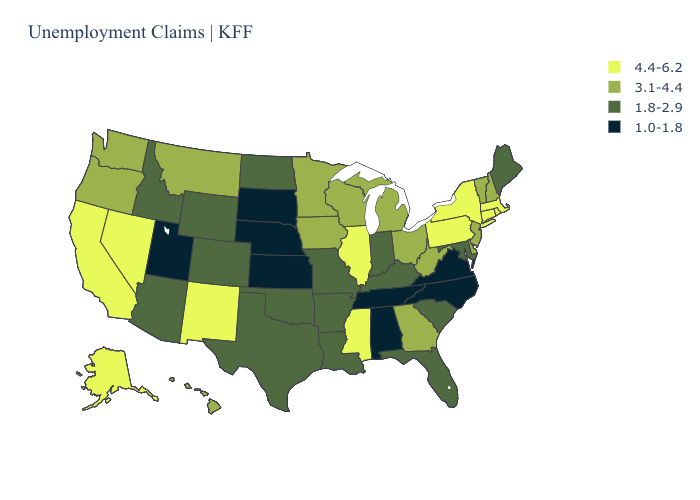What is the highest value in the USA?
Write a very short answer. 4.4-6.2. Among the states that border Michigan , does Wisconsin have the lowest value?
Concise answer only. No. Name the states that have a value in the range 1.0-1.8?
Give a very brief answer. Alabama, Kansas, Nebraska, North Carolina, South Dakota, Tennessee, Utah, Virginia. Does Illinois have the highest value in the MidWest?
Keep it brief. Yes. Name the states that have a value in the range 1.8-2.9?
Give a very brief answer. Arizona, Arkansas, Colorado, Florida, Idaho, Indiana, Kentucky, Louisiana, Maine, Maryland, Missouri, North Dakota, Oklahoma, South Carolina, Texas, Wyoming. What is the value of Pennsylvania?
Be succinct. 4.4-6.2. What is the value of New Mexico?
Give a very brief answer. 4.4-6.2. Does Iowa have the highest value in the USA?
Write a very short answer. No. Name the states that have a value in the range 4.4-6.2?
Write a very short answer. Alaska, California, Connecticut, Illinois, Massachusetts, Mississippi, Nevada, New Mexico, New York, Pennsylvania, Rhode Island. Does the first symbol in the legend represent the smallest category?
Short answer required. No. Name the states that have a value in the range 1.0-1.8?
Concise answer only. Alabama, Kansas, Nebraska, North Carolina, South Dakota, Tennessee, Utah, Virginia. Does New York have the highest value in the USA?
Concise answer only. Yes. Is the legend a continuous bar?
Answer briefly. No. Does Maine have the lowest value in the Northeast?
Keep it brief. Yes. What is the value of Arkansas?
Quick response, please. 1.8-2.9. 